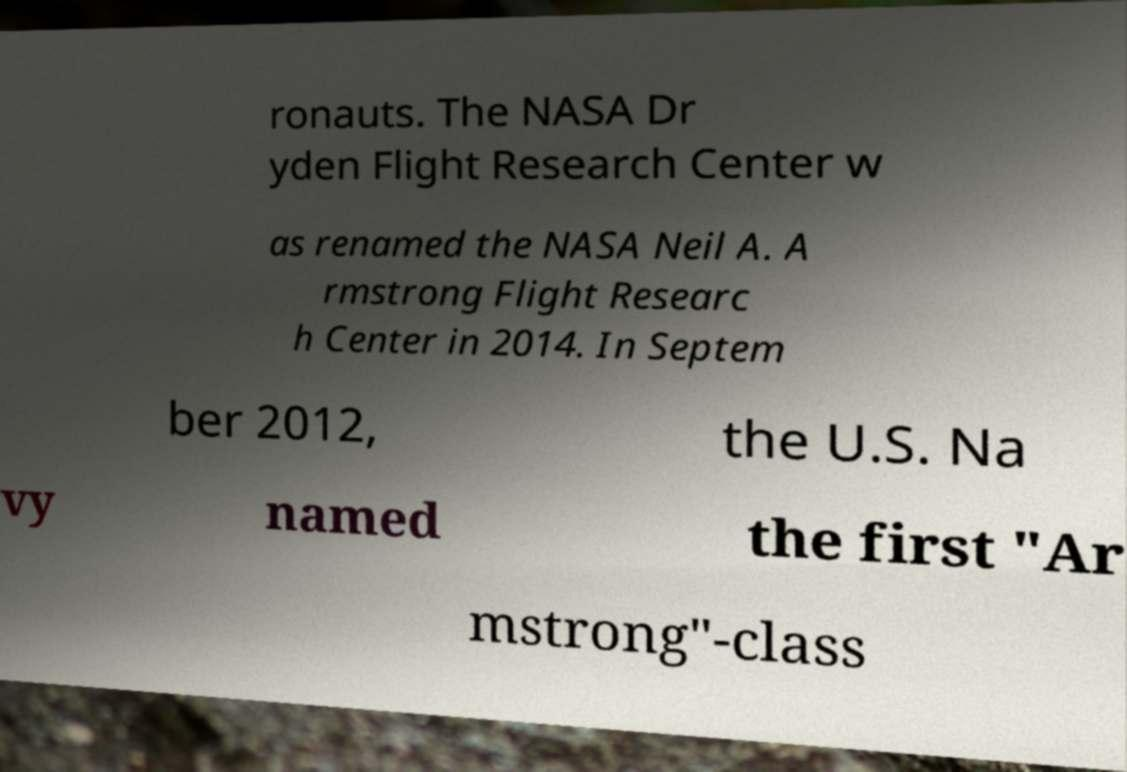What messages or text are displayed in this image? I need them in a readable, typed format. ronauts. The NASA Dr yden Flight Research Center w as renamed the NASA Neil A. A rmstrong Flight Researc h Center in 2014. In Septem ber 2012, the U.S. Na vy named the first "Ar mstrong"-class 